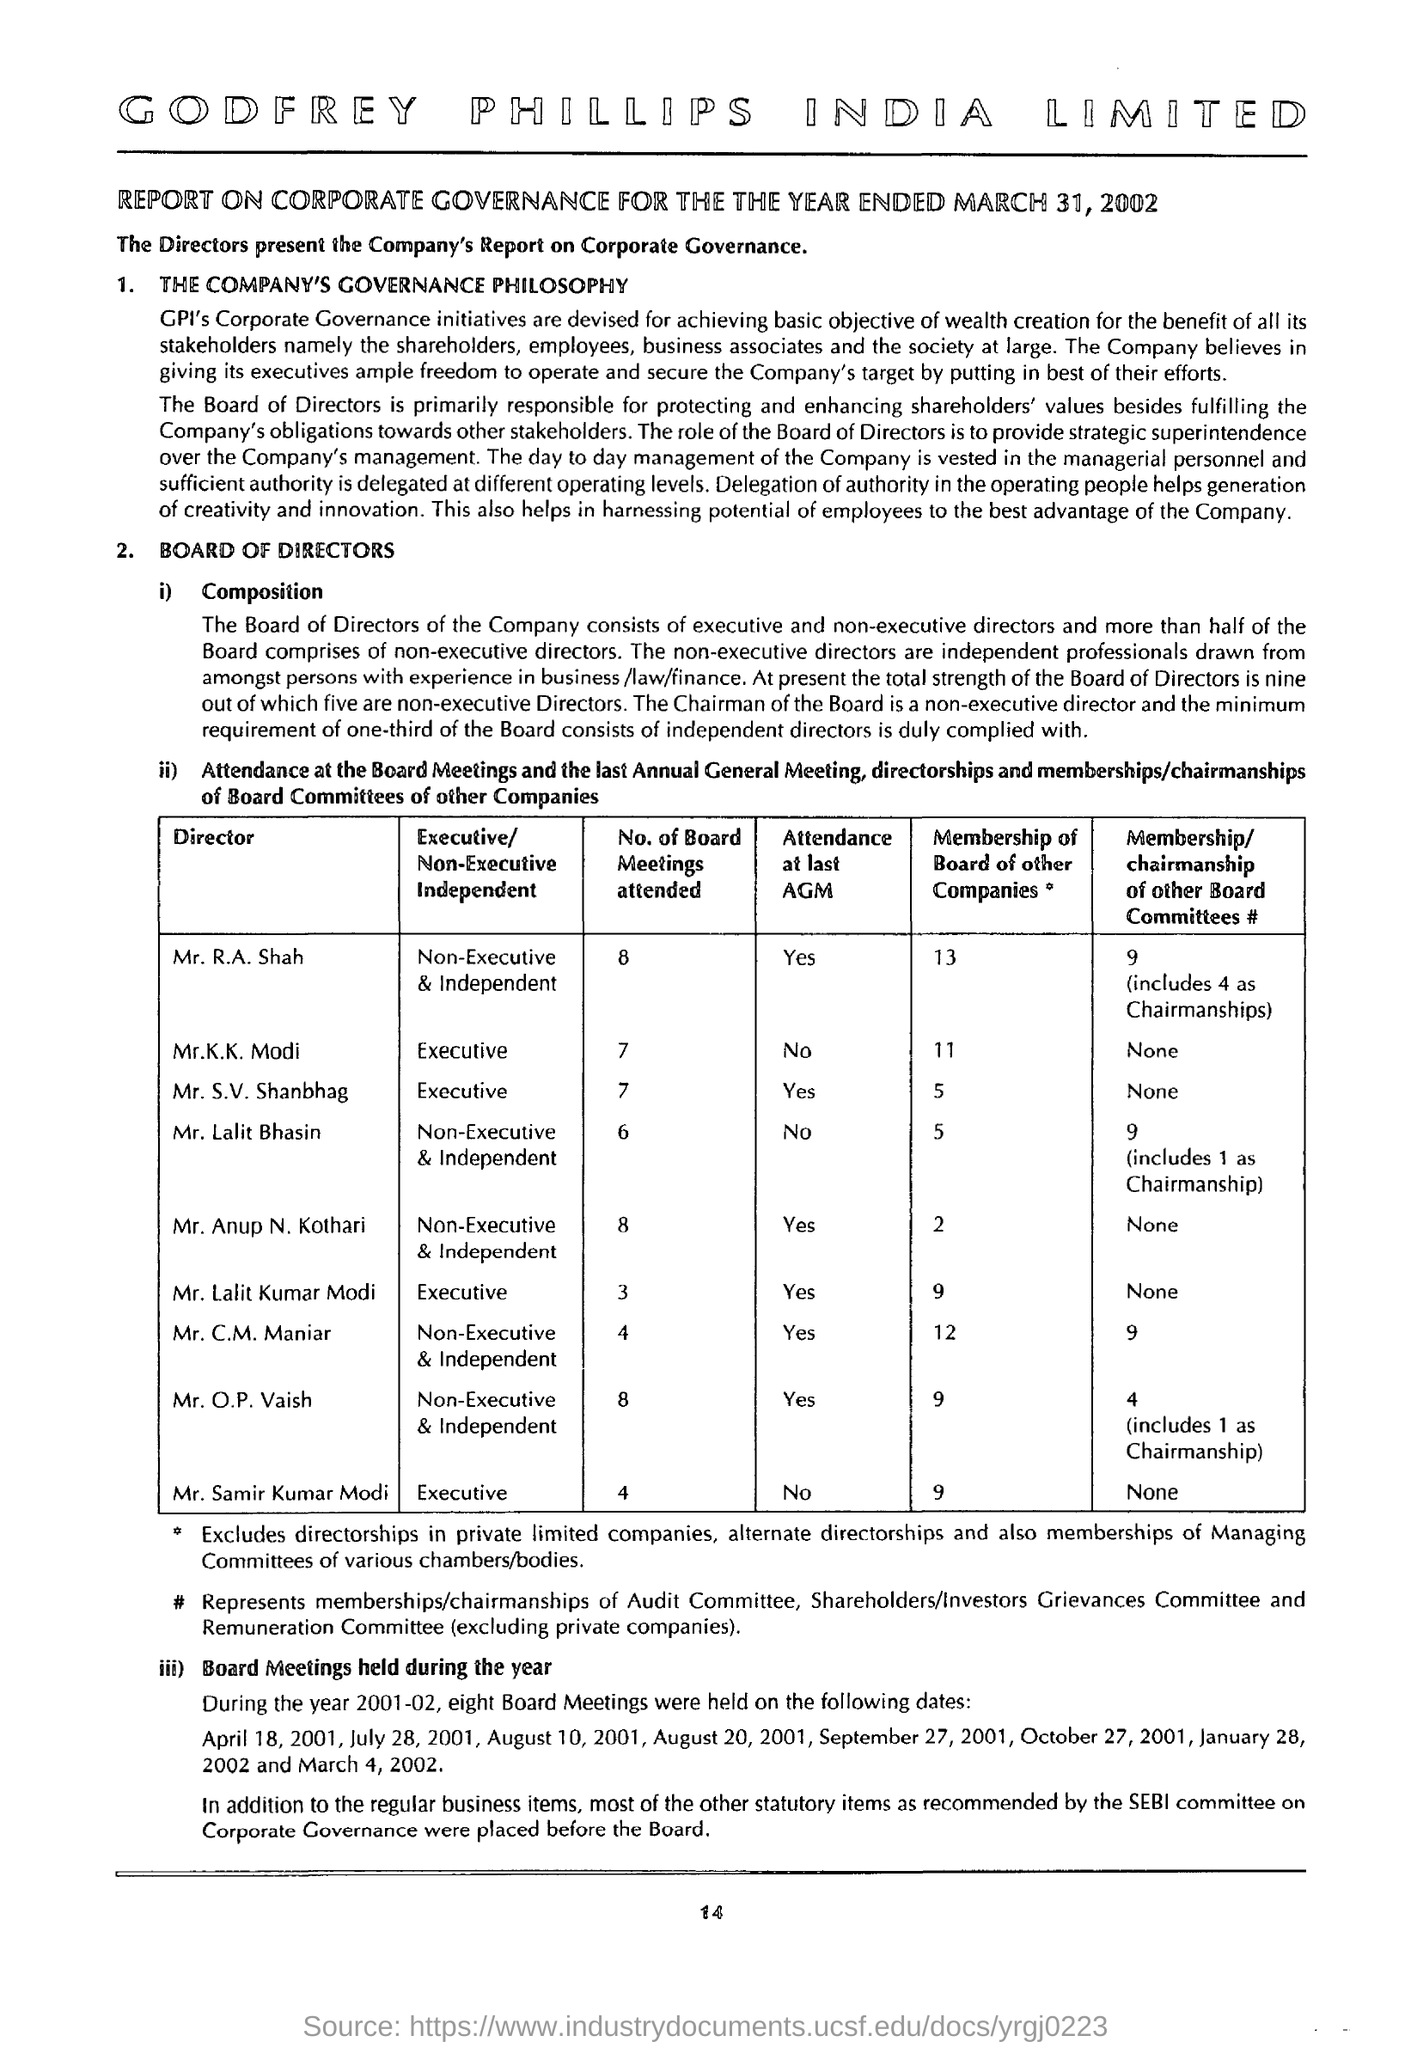How many board meetings are attended by the director mr. k.k.modi ?
Your answer should be compact. 7. How many membership of board of other companies are there for the director mr. c.m.maniar?
Offer a terse response. 12. What is the status of attendance at last agm for the director mr. anup n.kothari ?
Ensure brevity in your answer.  Yes. How many no of board meetings are attended by the director mr.o.p.vaish ?
Offer a terse response. 8. What is the status of attendance at last agm for the director mr. lalit kumar modi ?
Ensure brevity in your answer.  Yes. How many no of board meetings are attended by the director mr. lalit bhasin ?
Provide a succinct answer. 6. How many no of board meetings are attended by the director mr. k.k.modi ?
Your answer should be very brief. 7. 